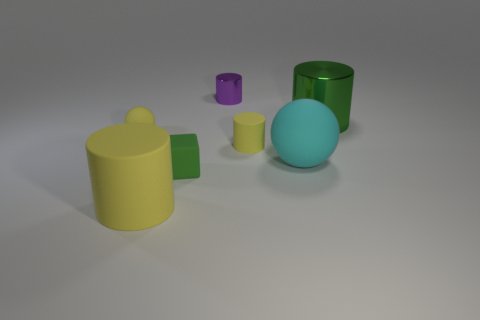There is a yellow ball; how many large metallic cylinders are to the left of it?
Provide a succinct answer. 0. What size is the yellow thing that is both left of the purple object and behind the small rubber cube?
Give a very brief answer. Small. Is there a shiny thing?
Your answer should be compact. Yes. What number of other objects are the same size as the green rubber block?
Keep it short and to the point. 3. There is a small cylinder that is in front of the large green shiny thing; is its color the same as the metallic object on the left side of the green metal cylinder?
Offer a terse response. No. The other shiny object that is the same shape as the purple thing is what size?
Ensure brevity in your answer.  Large. Are the yellow object that is to the right of the small green block and the yellow thing that is in front of the small green rubber cube made of the same material?
Give a very brief answer. Yes. What number of shiny things are cyan objects or small cylinders?
Provide a succinct answer. 1. There is a sphere to the left of the ball that is on the right side of the matte ball left of the big yellow matte object; what is it made of?
Your answer should be very brief. Rubber. Does the tiny thing behind the tiny yellow matte sphere have the same shape as the tiny yellow thing left of the green cube?
Make the answer very short. No. 